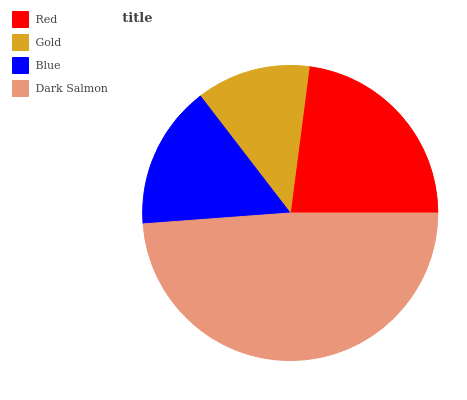Is Gold the minimum?
Answer yes or no. Yes. Is Dark Salmon the maximum?
Answer yes or no. Yes. Is Blue the minimum?
Answer yes or no. No. Is Blue the maximum?
Answer yes or no. No. Is Blue greater than Gold?
Answer yes or no. Yes. Is Gold less than Blue?
Answer yes or no. Yes. Is Gold greater than Blue?
Answer yes or no. No. Is Blue less than Gold?
Answer yes or no. No. Is Red the high median?
Answer yes or no. Yes. Is Blue the low median?
Answer yes or no. Yes. Is Dark Salmon the high median?
Answer yes or no. No. Is Red the low median?
Answer yes or no. No. 